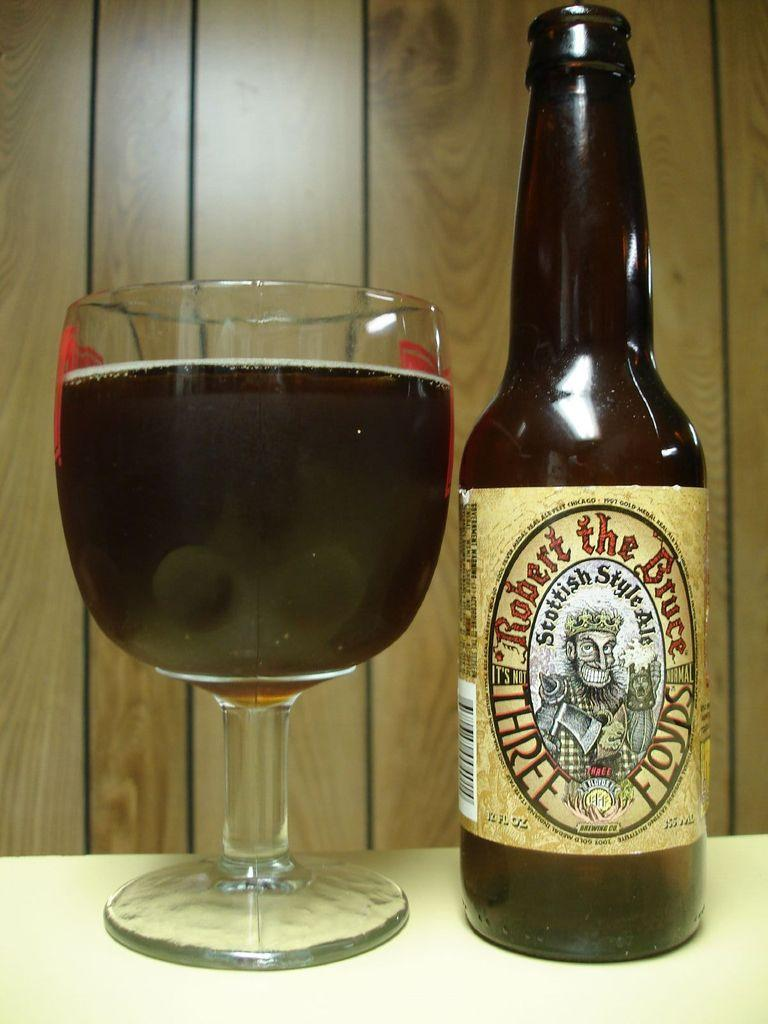<image>
Provide a brief description of the given image. A bottle with a Robert The Bruce label sits next to a full glass. 